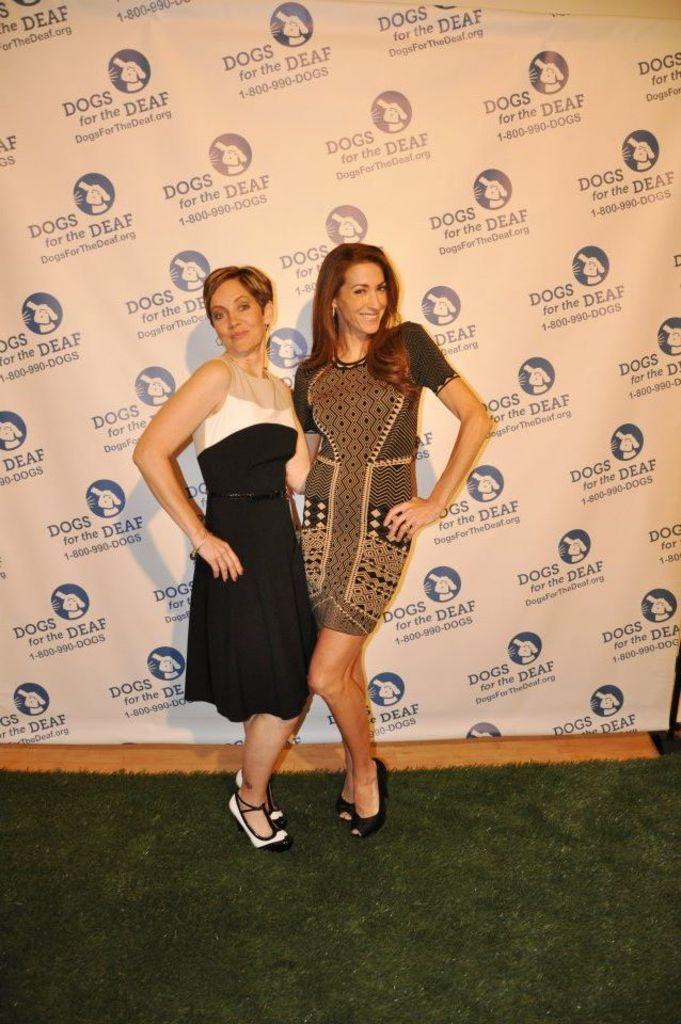Please provide a concise description of this image. In this image we can see two ladies. In the background of the image there is a banner and a wooden surface. At the bottom of the image there is the floor. 